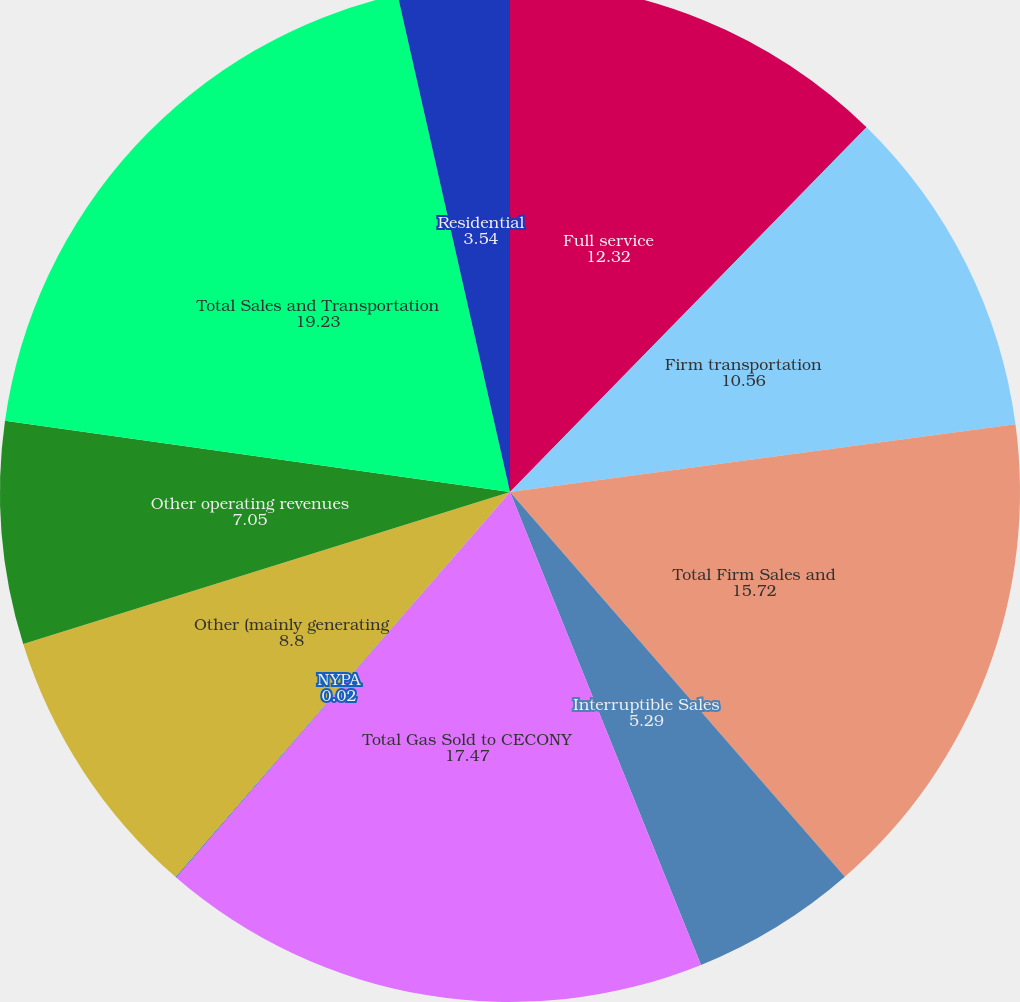<chart> <loc_0><loc_0><loc_500><loc_500><pie_chart><fcel>Full service<fcel>Firm transportation<fcel>Total Firm Sales and<fcel>Interruptible Sales<fcel>Total Gas Sold to CECONY<fcel>NYPA<fcel>Other (mainly generating<fcel>Other operating revenues<fcel>Total Sales and Transportation<fcel>Residential<nl><fcel>12.32%<fcel>10.56%<fcel>15.72%<fcel>5.29%<fcel>17.47%<fcel>0.02%<fcel>8.8%<fcel>7.05%<fcel>19.23%<fcel>3.54%<nl></chart> 